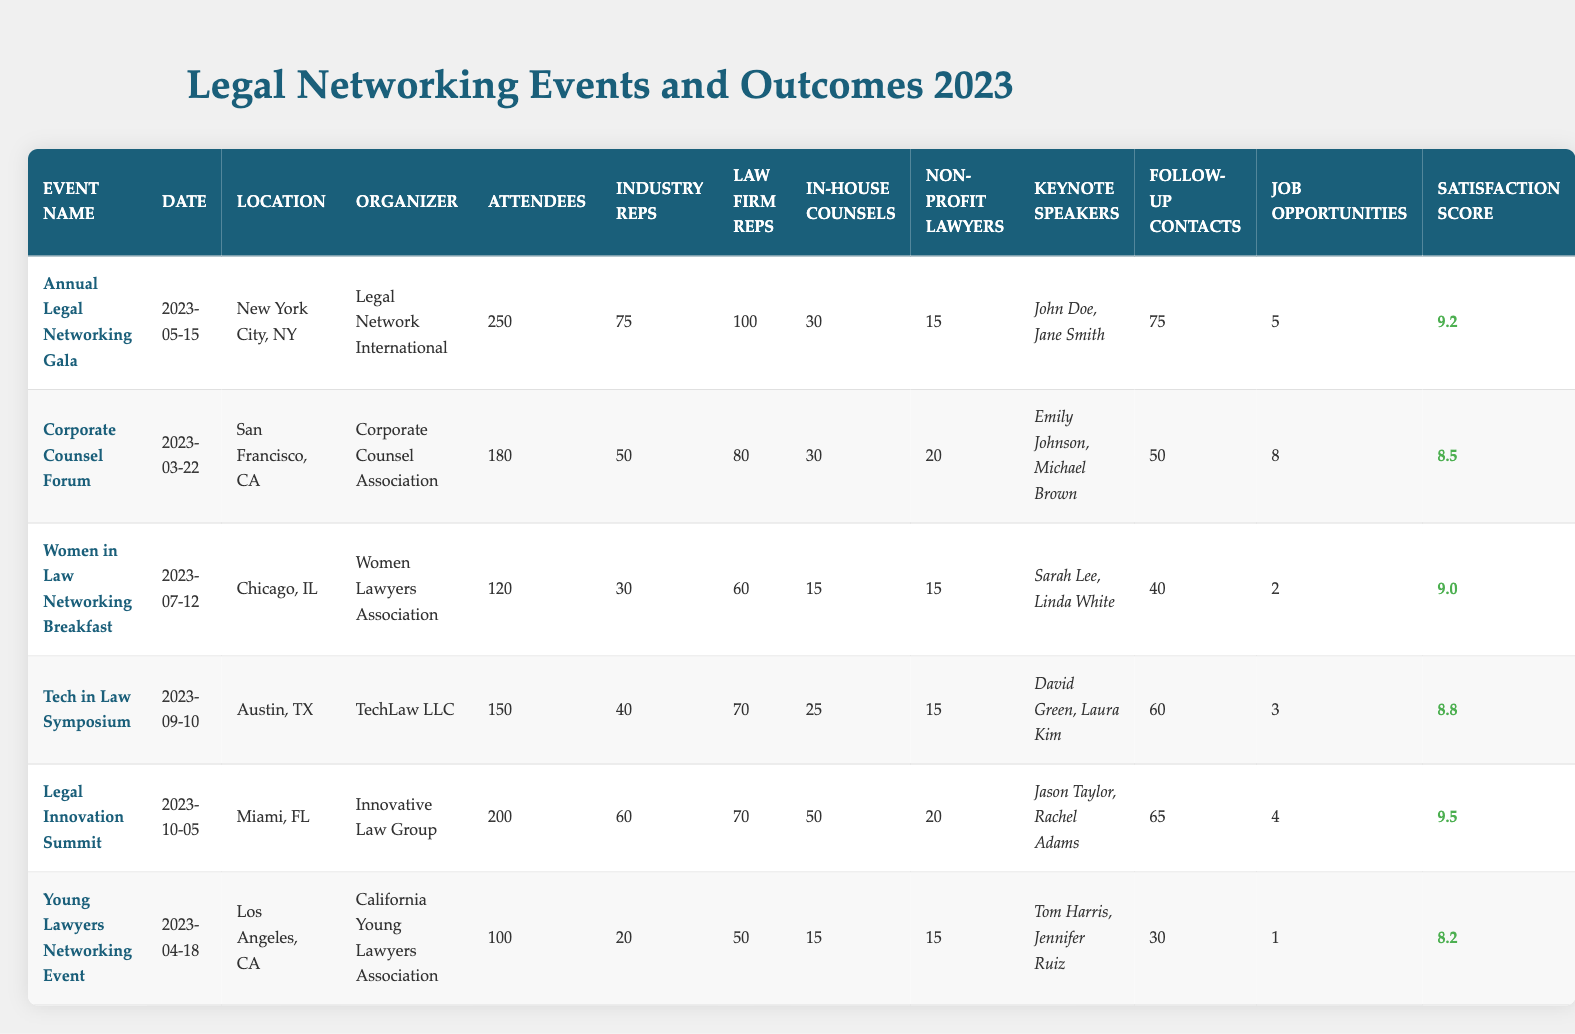What is the location of the Corporate Counsel Forum? The table lists the location of the Corporate Counsel Forum under the Location column, which shows "San Francisco, CA".
Answer: San Francisco, CA How many attendees were at the Women in Law Networking Breakfast? The number of attendees for the Women in Law Networking Breakfast can be found in the Attendees column, which states there were 120 attendees.
Answer: 120 What is the satisfaction score for the Legal Innovation Summit? The satisfaction score is recorded in the Satisfaction Score column for the Legal Innovation Summit, which shows a score of 9.5.
Answer: 9.5 Which event had the most law firm representatives? To find the event with the most law firm representatives, I compare the values in the Law Firm Representatives column. The Annual Legal Networking Gala has 100 representatives, which is the highest.
Answer: Annual Legal Networking Gala What is the total number of job opportunities identified across all events? To find the total, sum the job opportunities identified in the Job Opportunities column: 5 + 8 + 2 + 3 + 4 + 1 = 23.
Answer: 23 Which event had the lowest attendee satisfaction score? To find the lowest satisfaction score, I look at the Satisfaction Score column and find the minimum value, which belongs to the Young Lawyers Networking Event with a score of 8.2.
Answer: Young Lawyers Networking Event How many follow-up contacts were generated at the Tech in Law Symposium? The Follow-Up Contacts column for the Tech in Law Symposium indicates there were 60 follow-up contacts.
Answer: 60 What is the average number of attendees across all events? The total number of attendees is 250 + 180 + 120 + 150 + 200 + 100 = 1,000 across 6 events. Dividing gives an average of 1000 / 6 ≈ 166.67.
Answer: Approximately 166.67 Is it true that all events had at least 100 attendees? Checking the Attendees column, I see that the lowest value is 100 for the Young Lawyers Networking Event, which confirms that all events had at least 100 attendees.
Answer: Yes Which event was organized by the Women Lawyers Association? The event organized by the Women Lawyers Association is identified in the Organizer column, which shows the Women in Law Networking Breakfast.
Answer: Women in Law Networking Breakfast 